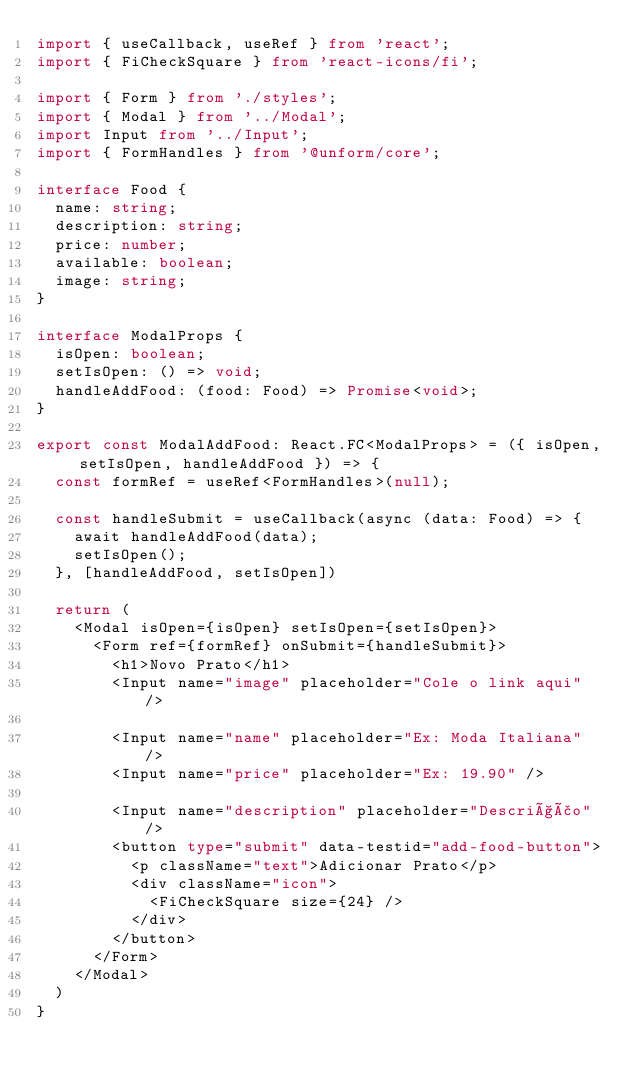Convert code to text. <code><loc_0><loc_0><loc_500><loc_500><_TypeScript_>import { useCallback, useRef } from 'react';
import { FiCheckSquare } from 'react-icons/fi';

import { Form } from './styles';
import { Modal } from '../Modal';
import Input from '../Input';
import { FormHandles } from '@unform/core';

interface Food {
  name: string;
  description: string;
  price: number;
  available: boolean;
  image: string;
}

interface ModalProps {
  isOpen: boolean;
  setIsOpen: () => void;
  handleAddFood: (food: Food) => Promise<void>;
}

export const ModalAddFood: React.FC<ModalProps> = ({ isOpen, setIsOpen, handleAddFood }) => {
  const formRef = useRef<FormHandles>(null);

  const handleSubmit = useCallback(async (data: Food) => {
    await handleAddFood(data);
    setIsOpen();
  }, [handleAddFood, setIsOpen])

  return (
    <Modal isOpen={isOpen} setIsOpen={setIsOpen}>
      <Form ref={formRef} onSubmit={handleSubmit}>
        <h1>Novo Prato</h1>
        <Input name="image" placeholder="Cole o link aqui" />

        <Input name="name" placeholder="Ex: Moda Italiana" />
        <Input name="price" placeholder="Ex: 19.90" />

        <Input name="description" placeholder="Descrição" />
        <button type="submit" data-testid="add-food-button">
          <p className="text">Adicionar Prato</p>
          <div className="icon">
            <FiCheckSquare size={24} />
          </div>
        </button>
      </Form>
    </Modal>
  )
}
</code> 